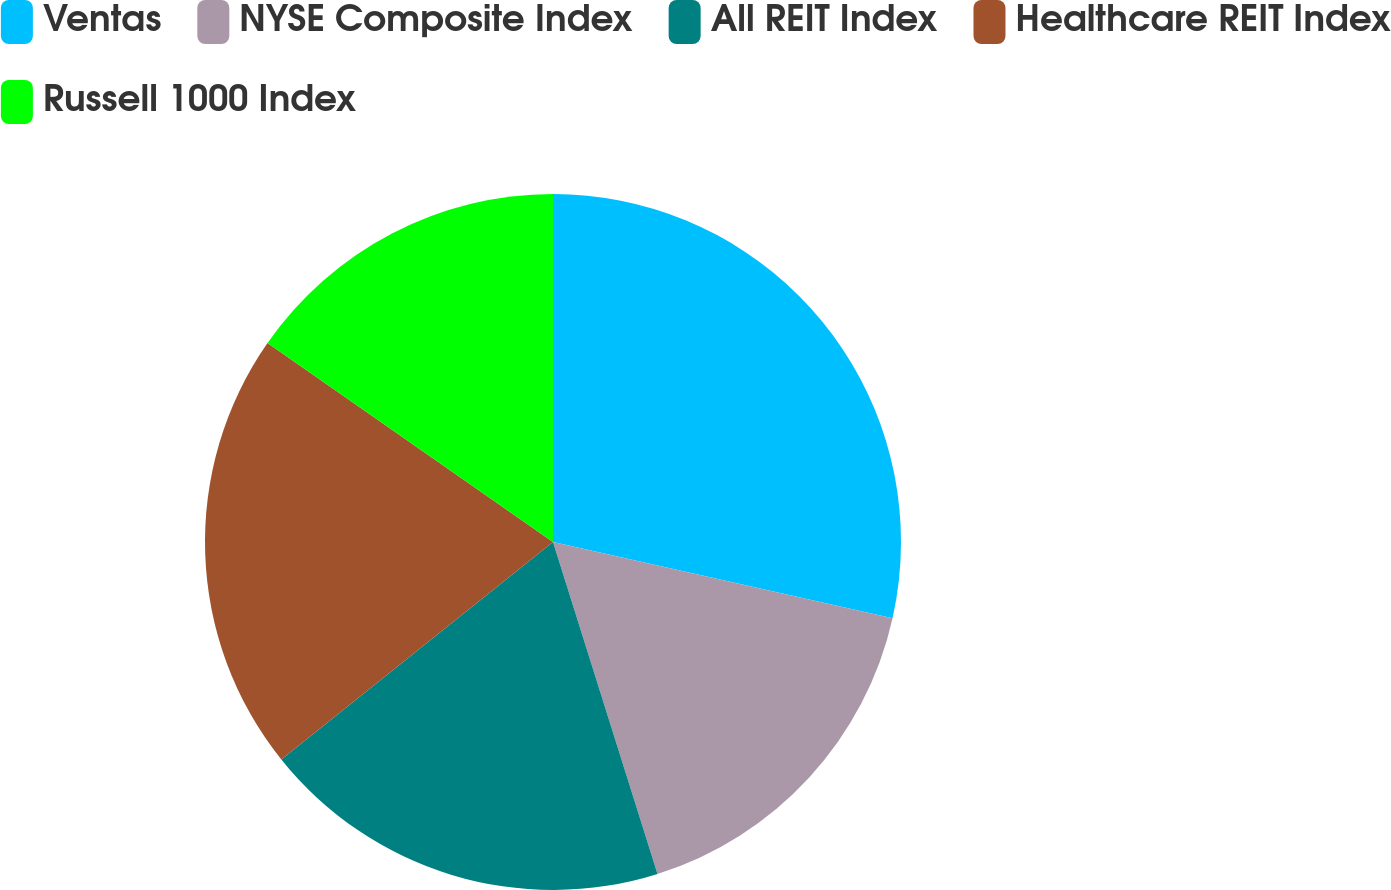Convert chart. <chart><loc_0><loc_0><loc_500><loc_500><pie_chart><fcel>Ventas<fcel>NYSE Composite Index<fcel>All REIT Index<fcel>Healthcare REIT Index<fcel>Russell 1000 Index<nl><fcel>28.51%<fcel>16.63%<fcel>19.11%<fcel>20.43%<fcel>15.31%<nl></chart> 